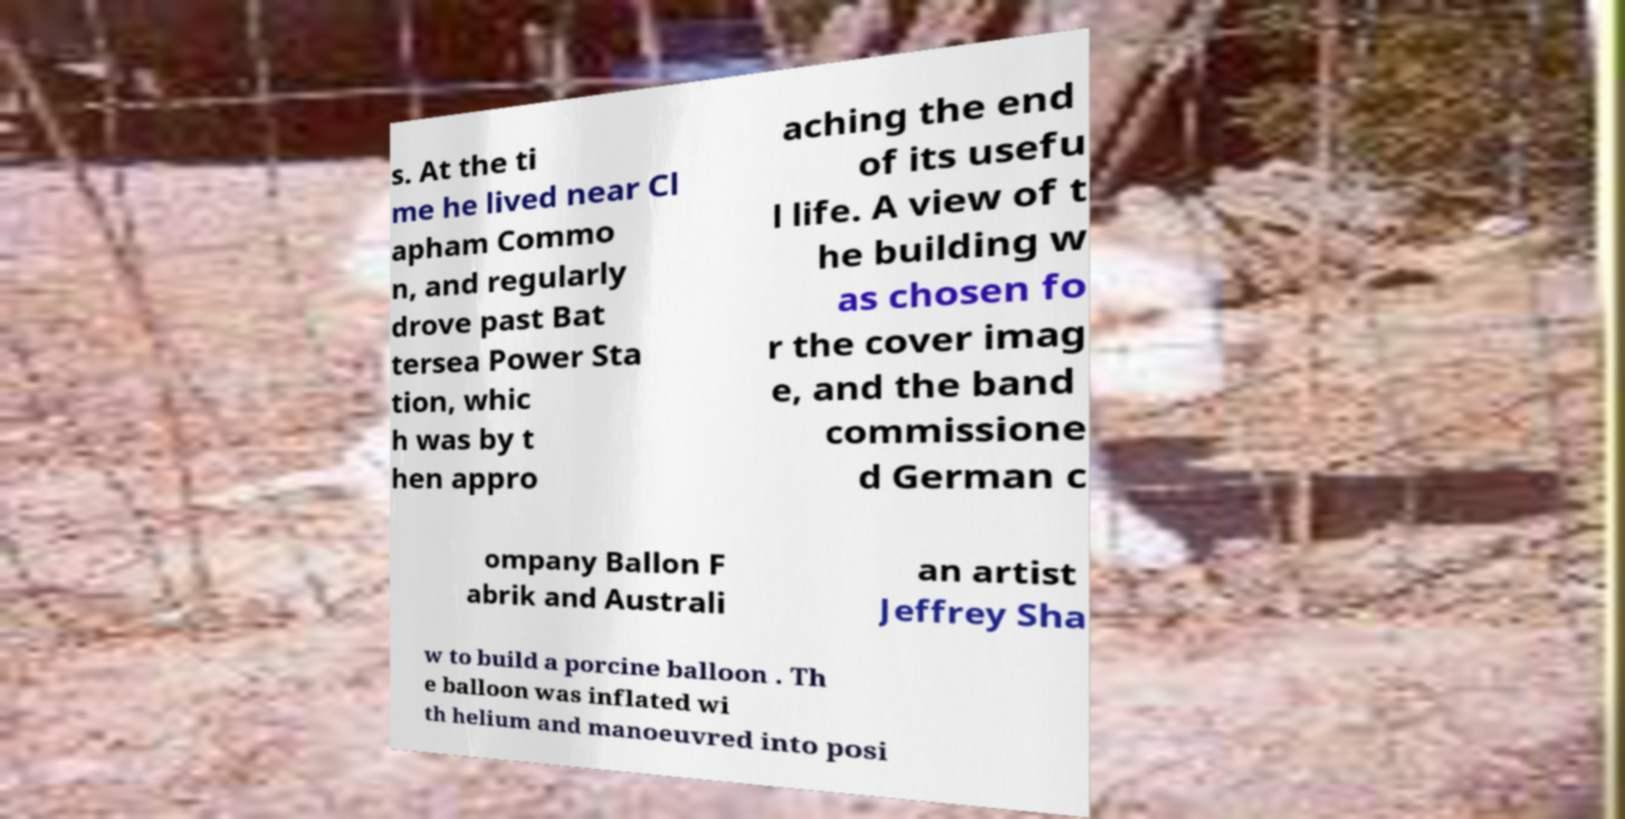Please read and relay the text visible in this image. What does it say? s. At the ti me he lived near Cl apham Commo n, and regularly drove past Bat tersea Power Sta tion, whic h was by t hen appro aching the end of its usefu l life. A view of t he building w as chosen fo r the cover imag e, and the band commissione d German c ompany Ballon F abrik and Australi an artist Jeffrey Sha w to build a porcine balloon . Th e balloon was inflated wi th helium and manoeuvred into posi 